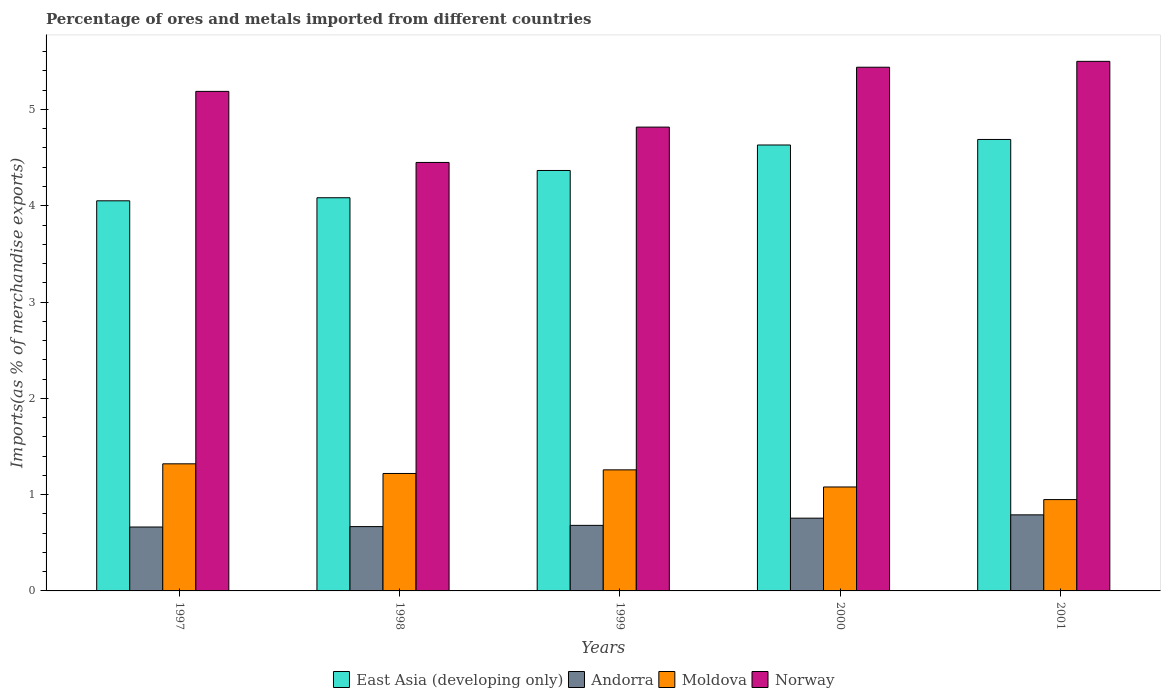How many different coloured bars are there?
Your answer should be very brief. 4. How many groups of bars are there?
Your answer should be very brief. 5. Are the number of bars on each tick of the X-axis equal?
Your answer should be very brief. Yes. In how many cases, is the number of bars for a given year not equal to the number of legend labels?
Make the answer very short. 0. What is the percentage of imports to different countries in Moldova in 2001?
Offer a very short reply. 0.95. Across all years, what is the maximum percentage of imports to different countries in East Asia (developing only)?
Your answer should be very brief. 4.69. Across all years, what is the minimum percentage of imports to different countries in Norway?
Your answer should be very brief. 4.45. In which year was the percentage of imports to different countries in Moldova maximum?
Your answer should be compact. 1997. In which year was the percentage of imports to different countries in Andorra minimum?
Provide a succinct answer. 1997. What is the total percentage of imports to different countries in Andorra in the graph?
Keep it short and to the point. 3.56. What is the difference between the percentage of imports to different countries in East Asia (developing only) in 2000 and that in 2001?
Provide a succinct answer. -0.06. What is the difference between the percentage of imports to different countries in Andorra in 1998 and the percentage of imports to different countries in Norway in 1997?
Give a very brief answer. -4.52. What is the average percentage of imports to different countries in Norway per year?
Your answer should be compact. 5.08. In the year 1999, what is the difference between the percentage of imports to different countries in Moldova and percentage of imports to different countries in Andorra?
Provide a short and direct response. 0.58. In how many years, is the percentage of imports to different countries in Moldova greater than 2.4 %?
Give a very brief answer. 0. What is the ratio of the percentage of imports to different countries in East Asia (developing only) in 1998 to that in 2001?
Provide a succinct answer. 0.87. Is the percentage of imports to different countries in East Asia (developing only) in 1998 less than that in 2001?
Your answer should be compact. Yes. What is the difference between the highest and the second highest percentage of imports to different countries in Norway?
Make the answer very short. 0.06. What is the difference between the highest and the lowest percentage of imports to different countries in East Asia (developing only)?
Keep it short and to the point. 0.64. In how many years, is the percentage of imports to different countries in Norway greater than the average percentage of imports to different countries in Norway taken over all years?
Give a very brief answer. 3. What does the 1st bar from the left in 2000 represents?
Your response must be concise. East Asia (developing only). What does the 2nd bar from the right in 1998 represents?
Ensure brevity in your answer.  Moldova. How many bars are there?
Your response must be concise. 20. Are all the bars in the graph horizontal?
Your answer should be very brief. No. What is the difference between two consecutive major ticks on the Y-axis?
Provide a succinct answer. 1. Are the values on the major ticks of Y-axis written in scientific E-notation?
Your answer should be very brief. No. Does the graph contain grids?
Your answer should be compact. No. Where does the legend appear in the graph?
Give a very brief answer. Bottom center. How are the legend labels stacked?
Offer a very short reply. Horizontal. What is the title of the graph?
Your answer should be very brief. Percentage of ores and metals imported from different countries. Does "El Salvador" appear as one of the legend labels in the graph?
Your answer should be compact. No. What is the label or title of the Y-axis?
Offer a very short reply. Imports(as % of merchandise exports). What is the Imports(as % of merchandise exports) in East Asia (developing only) in 1997?
Provide a short and direct response. 4.05. What is the Imports(as % of merchandise exports) in Andorra in 1997?
Offer a very short reply. 0.66. What is the Imports(as % of merchandise exports) of Moldova in 1997?
Your answer should be compact. 1.32. What is the Imports(as % of merchandise exports) in Norway in 1997?
Your response must be concise. 5.19. What is the Imports(as % of merchandise exports) of East Asia (developing only) in 1998?
Offer a very short reply. 4.08. What is the Imports(as % of merchandise exports) of Andorra in 1998?
Offer a terse response. 0.67. What is the Imports(as % of merchandise exports) in Moldova in 1998?
Keep it short and to the point. 1.22. What is the Imports(as % of merchandise exports) in Norway in 1998?
Provide a succinct answer. 4.45. What is the Imports(as % of merchandise exports) in East Asia (developing only) in 1999?
Your response must be concise. 4.37. What is the Imports(as % of merchandise exports) in Andorra in 1999?
Keep it short and to the point. 0.68. What is the Imports(as % of merchandise exports) in Moldova in 1999?
Provide a short and direct response. 1.26. What is the Imports(as % of merchandise exports) of Norway in 1999?
Provide a succinct answer. 4.82. What is the Imports(as % of merchandise exports) in East Asia (developing only) in 2000?
Your answer should be compact. 4.63. What is the Imports(as % of merchandise exports) in Andorra in 2000?
Give a very brief answer. 0.76. What is the Imports(as % of merchandise exports) of Moldova in 2000?
Offer a very short reply. 1.08. What is the Imports(as % of merchandise exports) of Norway in 2000?
Your answer should be compact. 5.44. What is the Imports(as % of merchandise exports) in East Asia (developing only) in 2001?
Offer a terse response. 4.69. What is the Imports(as % of merchandise exports) of Andorra in 2001?
Provide a short and direct response. 0.79. What is the Imports(as % of merchandise exports) of Moldova in 2001?
Offer a terse response. 0.95. What is the Imports(as % of merchandise exports) of Norway in 2001?
Offer a very short reply. 5.5. Across all years, what is the maximum Imports(as % of merchandise exports) of East Asia (developing only)?
Your response must be concise. 4.69. Across all years, what is the maximum Imports(as % of merchandise exports) in Andorra?
Your response must be concise. 0.79. Across all years, what is the maximum Imports(as % of merchandise exports) of Moldova?
Provide a short and direct response. 1.32. Across all years, what is the maximum Imports(as % of merchandise exports) of Norway?
Offer a very short reply. 5.5. Across all years, what is the minimum Imports(as % of merchandise exports) of East Asia (developing only)?
Give a very brief answer. 4.05. Across all years, what is the minimum Imports(as % of merchandise exports) in Andorra?
Give a very brief answer. 0.66. Across all years, what is the minimum Imports(as % of merchandise exports) of Moldova?
Offer a very short reply. 0.95. Across all years, what is the minimum Imports(as % of merchandise exports) in Norway?
Ensure brevity in your answer.  4.45. What is the total Imports(as % of merchandise exports) of East Asia (developing only) in the graph?
Make the answer very short. 21.82. What is the total Imports(as % of merchandise exports) in Andorra in the graph?
Make the answer very short. 3.56. What is the total Imports(as % of merchandise exports) of Moldova in the graph?
Offer a terse response. 5.83. What is the total Imports(as % of merchandise exports) in Norway in the graph?
Offer a terse response. 25.39. What is the difference between the Imports(as % of merchandise exports) of East Asia (developing only) in 1997 and that in 1998?
Your answer should be very brief. -0.03. What is the difference between the Imports(as % of merchandise exports) in Andorra in 1997 and that in 1998?
Provide a short and direct response. -0. What is the difference between the Imports(as % of merchandise exports) in Moldova in 1997 and that in 1998?
Your answer should be very brief. 0.1. What is the difference between the Imports(as % of merchandise exports) in Norway in 1997 and that in 1998?
Provide a short and direct response. 0.74. What is the difference between the Imports(as % of merchandise exports) in East Asia (developing only) in 1997 and that in 1999?
Offer a terse response. -0.32. What is the difference between the Imports(as % of merchandise exports) of Andorra in 1997 and that in 1999?
Your answer should be compact. -0.02. What is the difference between the Imports(as % of merchandise exports) in Moldova in 1997 and that in 1999?
Offer a very short reply. 0.06. What is the difference between the Imports(as % of merchandise exports) of Norway in 1997 and that in 1999?
Offer a very short reply. 0.37. What is the difference between the Imports(as % of merchandise exports) of East Asia (developing only) in 1997 and that in 2000?
Offer a very short reply. -0.58. What is the difference between the Imports(as % of merchandise exports) in Andorra in 1997 and that in 2000?
Offer a very short reply. -0.09. What is the difference between the Imports(as % of merchandise exports) of Moldova in 1997 and that in 2000?
Make the answer very short. 0.24. What is the difference between the Imports(as % of merchandise exports) in Norway in 1997 and that in 2000?
Offer a terse response. -0.25. What is the difference between the Imports(as % of merchandise exports) of East Asia (developing only) in 1997 and that in 2001?
Your response must be concise. -0.64. What is the difference between the Imports(as % of merchandise exports) of Andorra in 1997 and that in 2001?
Your response must be concise. -0.13. What is the difference between the Imports(as % of merchandise exports) in Moldova in 1997 and that in 2001?
Offer a terse response. 0.37. What is the difference between the Imports(as % of merchandise exports) in Norway in 1997 and that in 2001?
Keep it short and to the point. -0.31. What is the difference between the Imports(as % of merchandise exports) in East Asia (developing only) in 1998 and that in 1999?
Provide a short and direct response. -0.28. What is the difference between the Imports(as % of merchandise exports) in Andorra in 1998 and that in 1999?
Provide a short and direct response. -0.01. What is the difference between the Imports(as % of merchandise exports) in Moldova in 1998 and that in 1999?
Your answer should be compact. -0.04. What is the difference between the Imports(as % of merchandise exports) of Norway in 1998 and that in 1999?
Provide a succinct answer. -0.37. What is the difference between the Imports(as % of merchandise exports) in East Asia (developing only) in 1998 and that in 2000?
Offer a very short reply. -0.55. What is the difference between the Imports(as % of merchandise exports) of Andorra in 1998 and that in 2000?
Ensure brevity in your answer.  -0.09. What is the difference between the Imports(as % of merchandise exports) of Moldova in 1998 and that in 2000?
Give a very brief answer. 0.14. What is the difference between the Imports(as % of merchandise exports) of Norway in 1998 and that in 2000?
Offer a terse response. -0.99. What is the difference between the Imports(as % of merchandise exports) in East Asia (developing only) in 1998 and that in 2001?
Give a very brief answer. -0.61. What is the difference between the Imports(as % of merchandise exports) in Andorra in 1998 and that in 2001?
Ensure brevity in your answer.  -0.12. What is the difference between the Imports(as % of merchandise exports) of Moldova in 1998 and that in 2001?
Your response must be concise. 0.27. What is the difference between the Imports(as % of merchandise exports) of Norway in 1998 and that in 2001?
Ensure brevity in your answer.  -1.05. What is the difference between the Imports(as % of merchandise exports) of East Asia (developing only) in 1999 and that in 2000?
Offer a terse response. -0.26. What is the difference between the Imports(as % of merchandise exports) of Andorra in 1999 and that in 2000?
Keep it short and to the point. -0.07. What is the difference between the Imports(as % of merchandise exports) in Moldova in 1999 and that in 2000?
Offer a terse response. 0.18. What is the difference between the Imports(as % of merchandise exports) of Norway in 1999 and that in 2000?
Your response must be concise. -0.62. What is the difference between the Imports(as % of merchandise exports) in East Asia (developing only) in 1999 and that in 2001?
Make the answer very short. -0.32. What is the difference between the Imports(as % of merchandise exports) of Andorra in 1999 and that in 2001?
Provide a succinct answer. -0.11. What is the difference between the Imports(as % of merchandise exports) of Moldova in 1999 and that in 2001?
Offer a very short reply. 0.31. What is the difference between the Imports(as % of merchandise exports) of Norway in 1999 and that in 2001?
Offer a very short reply. -0.68. What is the difference between the Imports(as % of merchandise exports) in East Asia (developing only) in 2000 and that in 2001?
Offer a terse response. -0.06. What is the difference between the Imports(as % of merchandise exports) of Andorra in 2000 and that in 2001?
Provide a short and direct response. -0.03. What is the difference between the Imports(as % of merchandise exports) of Moldova in 2000 and that in 2001?
Your answer should be compact. 0.13. What is the difference between the Imports(as % of merchandise exports) of Norway in 2000 and that in 2001?
Provide a succinct answer. -0.06. What is the difference between the Imports(as % of merchandise exports) in East Asia (developing only) in 1997 and the Imports(as % of merchandise exports) in Andorra in 1998?
Your response must be concise. 3.38. What is the difference between the Imports(as % of merchandise exports) of East Asia (developing only) in 1997 and the Imports(as % of merchandise exports) of Moldova in 1998?
Make the answer very short. 2.83. What is the difference between the Imports(as % of merchandise exports) in East Asia (developing only) in 1997 and the Imports(as % of merchandise exports) in Norway in 1998?
Ensure brevity in your answer.  -0.4. What is the difference between the Imports(as % of merchandise exports) in Andorra in 1997 and the Imports(as % of merchandise exports) in Moldova in 1998?
Keep it short and to the point. -0.56. What is the difference between the Imports(as % of merchandise exports) in Andorra in 1997 and the Imports(as % of merchandise exports) in Norway in 1998?
Offer a terse response. -3.79. What is the difference between the Imports(as % of merchandise exports) of Moldova in 1997 and the Imports(as % of merchandise exports) of Norway in 1998?
Give a very brief answer. -3.13. What is the difference between the Imports(as % of merchandise exports) in East Asia (developing only) in 1997 and the Imports(as % of merchandise exports) in Andorra in 1999?
Ensure brevity in your answer.  3.37. What is the difference between the Imports(as % of merchandise exports) in East Asia (developing only) in 1997 and the Imports(as % of merchandise exports) in Moldova in 1999?
Ensure brevity in your answer.  2.79. What is the difference between the Imports(as % of merchandise exports) of East Asia (developing only) in 1997 and the Imports(as % of merchandise exports) of Norway in 1999?
Your answer should be very brief. -0.77. What is the difference between the Imports(as % of merchandise exports) in Andorra in 1997 and the Imports(as % of merchandise exports) in Moldova in 1999?
Make the answer very short. -0.59. What is the difference between the Imports(as % of merchandise exports) in Andorra in 1997 and the Imports(as % of merchandise exports) in Norway in 1999?
Ensure brevity in your answer.  -4.15. What is the difference between the Imports(as % of merchandise exports) in Moldova in 1997 and the Imports(as % of merchandise exports) in Norway in 1999?
Provide a short and direct response. -3.5. What is the difference between the Imports(as % of merchandise exports) in East Asia (developing only) in 1997 and the Imports(as % of merchandise exports) in Andorra in 2000?
Offer a terse response. 3.3. What is the difference between the Imports(as % of merchandise exports) of East Asia (developing only) in 1997 and the Imports(as % of merchandise exports) of Moldova in 2000?
Give a very brief answer. 2.97. What is the difference between the Imports(as % of merchandise exports) in East Asia (developing only) in 1997 and the Imports(as % of merchandise exports) in Norway in 2000?
Offer a very short reply. -1.39. What is the difference between the Imports(as % of merchandise exports) of Andorra in 1997 and the Imports(as % of merchandise exports) of Moldova in 2000?
Make the answer very short. -0.42. What is the difference between the Imports(as % of merchandise exports) in Andorra in 1997 and the Imports(as % of merchandise exports) in Norway in 2000?
Your answer should be very brief. -4.78. What is the difference between the Imports(as % of merchandise exports) in Moldova in 1997 and the Imports(as % of merchandise exports) in Norway in 2000?
Make the answer very short. -4.12. What is the difference between the Imports(as % of merchandise exports) of East Asia (developing only) in 1997 and the Imports(as % of merchandise exports) of Andorra in 2001?
Offer a terse response. 3.26. What is the difference between the Imports(as % of merchandise exports) in East Asia (developing only) in 1997 and the Imports(as % of merchandise exports) in Moldova in 2001?
Keep it short and to the point. 3.1. What is the difference between the Imports(as % of merchandise exports) in East Asia (developing only) in 1997 and the Imports(as % of merchandise exports) in Norway in 2001?
Make the answer very short. -1.45. What is the difference between the Imports(as % of merchandise exports) of Andorra in 1997 and the Imports(as % of merchandise exports) of Moldova in 2001?
Give a very brief answer. -0.28. What is the difference between the Imports(as % of merchandise exports) of Andorra in 1997 and the Imports(as % of merchandise exports) of Norway in 2001?
Ensure brevity in your answer.  -4.84. What is the difference between the Imports(as % of merchandise exports) of Moldova in 1997 and the Imports(as % of merchandise exports) of Norway in 2001?
Provide a succinct answer. -4.18. What is the difference between the Imports(as % of merchandise exports) in East Asia (developing only) in 1998 and the Imports(as % of merchandise exports) in Andorra in 1999?
Ensure brevity in your answer.  3.4. What is the difference between the Imports(as % of merchandise exports) in East Asia (developing only) in 1998 and the Imports(as % of merchandise exports) in Moldova in 1999?
Offer a very short reply. 2.83. What is the difference between the Imports(as % of merchandise exports) of East Asia (developing only) in 1998 and the Imports(as % of merchandise exports) of Norway in 1999?
Make the answer very short. -0.73. What is the difference between the Imports(as % of merchandise exports) in Andorra in 1998 and the Imports(as % of merchandise exports) in Moldova in 1999?
Provide a short and direct response. -0.59. What is the difference between the Imports(as % of merchandise exports) in Andorra in 1998 and the Imports(as % of merchandise exports) in Norway in 1999?
Your answer should be very brief. -4.15. What is the difference between the Imports(as % of merchandise exports) of Moldova in 1998 and the Imports(as % of merchandise exports) of Norway in 1999?
Give a very brief answer. -3.6. What is the difference between the Imports(as % of merchandise exports) in East Asia (developing only) in 1998 and the Imports(as % of merchandise exports) in Andorra in 2000?
Ensure brevity in your answer.  3.33. What is the difference between the Imports(as % of merchandise exports) in East Asia (developing only) in 1998 and the Imports(as % of merchandise exports) in Moldova in 2000?
Keep it short and to the point. 3. What is the difference between the Imports(as % of merchandise exports) of East Asia (developing only) in 1998 and the Imports(as % of merchandise exports) of Norway in 2000?
Keep it short and to the point. -1.36. What is the difference between the Imports(as % of merchandise exports) in Andorra in 1998 and the Imports(as % of merchandise exports) in Moldova in 2000?
Your response must be concise. -0.41. What is the difference between the Imports(as % of merchandise exports) of Andorra in 1998 and the Imports(as % of merchandise exports) of Norway in 2000?
Provide a short and direct response. -4.77. What is the difference between the Imports(as % of merchandise exports) in Moldova in 1998 and the Imports(as % of merchandise exports) in Norway in 2000?
Ensure brevity in your answer.  -4.22. What is the difference between the Imports(as % of merchandise exports) in East Asia (developing only) in 1998 and the Imports(as % of merchandise exports) in Andorra in 2001?
Ensure brevity in your answer.  3.29. What is the difference between the Imports(as % of merchandise exports) of East Asia (developing only) in 1998 and the Imports(as % of merchandise exports) of Moldova in 2001?
Offer a very short reply. 3.13. What is the difference between the Imports(as % of merchandise exports) in East Asia (developing only) in 1998 and the Imports(as % of merchandise exports) in Norway in 2001?
Your response must be concise. -1.42. What is the difference between the Imports(as % of merchandise exports) of Andorra in 1998 and the Imports(as % of merchandise exports) of Moldova in 2001?
Ensure brevity in your answer.  -0.28. What is the difference between the Imports(as % of merchandise exports) in Andorra in 1998 and the Imports(as % of merchandise exports) in Norway in 2001?
Provide a succinct answer. -4.83. What is the difference between the Imports(as % of merchandise exports) of Moldova in 1998 and the Imports(as % of merchandise exports) of Norway in 2001?
Your answer should be compact. -4.28. What is the difference between the Imports(as % of merchandise exports) in East Asia (developing only) in 1999 and the Imports(as % of merchandise exports) in Andorra in 2000?
Ensure brevity in your answer.  3.61. What is the difference between the Imports(as % of merchandise exports) of East Asia (developing only) in 1999 and the Imports(as % of merchandise exports) of Moldova in 2000?
Make the answer very short. 3.29. What is the difference between the Imports(as % of merchandise exports) of East Asia (developing only) in 1999 and the Imports(as % of merchandise exports) of Norway in 2000?
Offer a terse response. -1.07. What is the difference between the Imports(as % of merchandise exports) in Andorra in 1999 and the Imports(as % of merchandise exports) in Moldova in 2000?
Your response must be concise. -0.4. What is the difference between the Imports(as % of merchandise exports) of Andorra in 1999 and the Imports(as % of merchandise exports) of Norway in 2000?
Your response must be concise. -4.76. What is the difference between the Imports(as % of merchandise exports) in Moldova in 1999 and the Imports(as % of merchandise exports) in Norway in 2000?
Offer a terse response. -4.18. What is the difference between the Imports(as % of merchandise exports) in East Asia (developing only) in 1999 and the Imports(as % of merchandise exports) in Andorra in 2001?
Your response must be concise. 3.58. What is the difference between the Imports(as % of merchandise exports) of East Asia (developing only) in 1999 and the Imports(as % of merchandise exports) of Moldova in 2001?
Your answer should be compact. 3.42. What is the difference between the Imports(as % of merchandise exports) of East Asia (developing only) in 1999 and the Imports(as % of merchandise exports) of Norway in 2001?
Ensure brevity in your answer.  -1.13. What is the difference between the Imports(as % of merchandise exports) in Andorra in 1999 and the Imports(as % of merchandise exports) in Moldova in 2001?
Your answer should be compact. -0.27. What is the difference between the Imports(as % of merchandise exports) in Andorra in 1999 and the Imports(as % of merchandise exports) in Norway in 2001?
Keep it short and to the point. -4.82. What is the difference between the Imports(as % of merchandise exports) of Moldova in 1999 and the Imports(as % of merchandise exports) of Norway in 2001?
Make the answer very short. -4.24. What is the difference between the Imports(as % of merchandise exports) of East Asia (developing only) in 2000 and the Imports(as % of merchandise exports) of Andorra in 2001?
Provide a short and direct response. 3.84. What is the difference between the Imports(as % of merchandise exports) of East Asia (developing only) in 2000 and the Imports(as % of merchandise exports) of Moldova in 2001?
Offer a very short reply. 3.68. What is the difference between the Imports(as % of merchandise exports) of East Asia (developing only) in 2000 and the Imports(as % of merchandise exports) of Norway in 2001?
Your answer should be very brief. -0.87. What is the difference between the Imports(as % of merchandise exports) in Andorra in 2000 and the Imports(as % of merchandise exports) in Moldova in 2001?
Your answer should be compact. -0.19. What is the difference between the Imports(as % of merchandise exports) of Andorra in 2000 and the Imports(as % of merchandise exports) of Norway in 2001?
Keep it short and to the point. -4.74. What is the difference between the Imports(as % of merchandise exports) in Moldova in 2000 and the Imports(as % of merchandise exports) in Norway in 2001?
Provide a short and direct response. -4.42. What is the average Imports(as % of merchandise exports) in East Asia (developing only) per year?
Provide a short and direct response. 4.36. What is the average Imports(as % of merchandise exports) in Andorra per year?
Keep it short and to the point. 0.71. What is the average Imports(as % of merchandise exports) in Moldova per year?
Offer a very short reply. 1.17. What is the average Imports(as % of merchandise exports) in Norway per year?
Give a very brief answer. 5.08. In the year 1997, what is the difference between the Imports(as % of merchandise exports) in East Asia (developing only) and Imports(as % of merchandise exports) in Andorra?
Your response must be concise. 3.39. In the year 1997, what is the difference between the Imports(as % of merchandise exports) of East Asia (developing only) and Imports(as % of merchandise exports) of Moldova?
Provide a succinct answer. 2.73. In the year 1997, what is the difference between the Imports(as % of merchandise exports) of East Asia (developing only) and Imports(as % of merchandise exports) of Norway?
Provide a succinct answer. -1.14. In the year 1997, what is the difference between the Imports(as % of merchandise exports) in Andorra and Imports(as % of merchandise exports) in Moldova?
Offer a very short reply. -0.66. In the year 1997, what is the difference between the Imports(as % of merchandise exports) of Andorra and Imports(as % of merchandise exports) of Norway?
Provide a short and direct response. -4.52. In the year 1997, what is the difference between the Imports(as % of merchandise exports) of Moldova and Imports(as % of merchandise exports) of Norway?
Offer a terse response. -3.87. In the year 1998, what is the difference between the Imports(as % of merchandise exports) of East Asia (developing only) and Imports(as % of merchandise exports) of Andorra?
Your answer should be very brief. 3.42. In the year 1998, what is the difference between the Imports(as % of merchandise exports) of East Asia (developing only) and Imports(as % of merchandise exports) of Moldova?
Provide a succinct answer. 2.86. In the year 1998, what is the difference between the Imports(as % of merchandise exports) of East Asia (developing only) and Imports(as % of merchandise exports) of Norway?
Give a very brief answer. -0.37. In the year 1998, what is the difference between the Imports(as % of merchandise exports) of Andorra and Imports(as % of merchandise exports) of Moldova?
Offer a terse response. -0.55. In the year 1998, what is the difference between the Imports(as % of merchandise exports) in Andorra and Imports(as % of merchandise exports) in Norway?
Ensure brevity in your answer.  -3.78. In the year 1998, what is the difference between the Imports(as % of merchandise exports) of Moldova and Imports(as % of merchandise exports) of Norway?
Your answer should be compact. -3.23. In the year 1999, what is the difference between the Imports(as % of merchandise exports) of East Asia (developing only) and Imports(as % of merchandise exports) of Andorra?
Offer a very short reply. 3.69. In the year 1999, what is the difference between the Imports(as % of merchandise exports) of East Asia (developing only) and Imports(as % of merchandise exports) of Moldova?
Provide a short and direct response. 3.11. In the year 1999, what is the difference between the Imports(as % of merchandise exports) in East Asia (developing only) and Imports(as % of merchandise exports) in Norway?
Your answer should be compact. -0.45. In the year 1999, what is the difference between the Imports(as % of merchandise exports) of Andorra and Imports(as % of merchandise exports) of Moldova?
Offer a terse response. -0.58. In the year 1999, what is the difference between the Imports(as % of merchandise exports) in Andorra and Imports(as % of merchandise exports) in Norway?
Keep it short and to the point. -4.14. In the year 1999, what is the difference between the Imports(as % of merchandise exports) in Moldova and Imports(as % of merchandise exports) in Norway?
Ensure brevity in your answer.  -3.56. In the year 2000, what is the difference between the Imports(as % of merchandise exports) in East Asia (developing only) and Imports(as % of merchandise exports) in Andorra?
Make the answer very short. 3.88. In the year 2000, what is the difference between the Imports(as % of merchandise exports) of East Asia (developing only) and Imports(as % of merchandise exports) of Moldova?
Provide a succinct answer. 3.55. In the year 2000, what is the difference between the Imports(as % of merchandise exports) in East Asia (developing only) and Imports(as % of merchandise exports) in Norway?
Provide a short and direct response. -0.81. In the year 2000, what is the difference between the Imports(as % of merchandise exports) of Andorra and Imports(as % of merchandise exports) of Moldova?
Give a very brief answer. -0.32. In the year 2000, what is the difference between the Imports(as % of merchandise exports) in Andorra and Imports(as % of merchandise exports) in Norway?
Ensure brevity in your answer.  -4.68. In the year 2000, what is the difference between the Imports(as % of merchandise exports) of Moldova and Imports(as % of merchandise exports) of Norway?
Your response must be concise. -4.36. In the year 2001, what is the difference between the Imports(as % of merchandise exports) of East Asia (developing only) and Imports(as % of merchandise exports) of Andorra?
Make the answer very short. 3.9. In the year 2001, what is the difference between the Imports(as % of merchandise exports) of East Asia (developing only) and Imports(as % of merchandise exports) of Moldova?
Keep it short and to the point. 3.74. In the year 2001, what is the difference between the Imports(as % of merchandise exports) of East Asia (developing only) and Imports(as % of merchandise exports) of Norway?
Ensure brevity in your answer.  -0.81. In the year 2001, what is the difference between the Imports(as % of merchandise exports) in Andorra and Imports(as % of merchandise exports) in Moldova?
Keep it short and to the point. -0.16. In the year 2001, what is the difference between the Imports(as % of merchandise exports) in Andorra and Imports(as % of merchandise exports) in Norway?
Offer a terse response. -4.71. In the year 2001, what is the difference between the Imports(as % of merchandise exports) of Moldova and Imports(as % of merchandise exports) of Norway?
Keep it short and to the point. -4.55. What is the ratio of the Imports(as % of merchandise exports) in Andorra in 1997 to that in 1998?
Your response must be concise. 0.99. What is the ratio of the Imports(as % of merchandise exports) in Moldova in 1997 to that in 1998?
Make the answer very short. 1.08. What is the ratio of the Imports(as % of merchandise exports) in Norway in 1997 to that in 1998?
Offer a terse response. 1.17. What is the ratio of the Imports(as % of merchandise exports) of East Asia (developing only) in 1997 to that in 1999?
Offer a very short reply. 0.93. What is the ratio of the Imports(as % of merchandise exports) of Andorra in 1997 to that in 1999?
Give a very brief answer. 0.98. What is the ratio of the Imports(as % of merchandise exports) in Moldova in 1997 to that in 1999?
Provide a short and direct response. 1.05. What is the ratio of the Imports(as % of merchandise exports) in Norway in 1997 to that in 1999?
Give a very brief answer. 1.08. What is the ratio of the Imports(as % of merchandise exports) of East Asia (developing only) in 1997 to that in 2000?
Provide a short and direct response. 0.87. What is the ratio of the Imports(as % of merchandise exports) in Andorra in 1997 to that in 2000?
Your answer should be very brief. 0.88. What is the ratio of the Imports(as % of merchandise exports) of Moldova in 1997 to that in 2000?
Offer a terse response. 1.22. What is the ratio of the Imports(as % of merchandise exports) in Norway in 1997 to that in 2000?
Offer a terse response. 0.95. What is the ratio of the Imports(as % of merchandise exports) in East Asia (developing only) in 1997 to that in 2001?
Your answer should be very brief. 0.86. What is the ratio of the Imports(as % of merchandise exports) in Andorra in 1997 to that in 2001?
Your answer should be compact. 0.84. What is the ratio of the Imports(as % of merchandise exports) in Moldova in 1997 to that in 2001?
Ensure brevity in your answer.  1.39. What is the ratio of the Imports(as % of merchandise exports) in Norway in 1997 to that in 2001?
Your answer should be very brief. 0.94. What is the ratio of the Imports(as % of merchandise exports) of East Asia (developing only) in 1998 to that in 1999?
Provide a short and direct response. 0.94. What is the ratio of the Imports(as % of merchandise exports) of Andorra in 1998 to that in 1999?
Offer a terse response. 0.98. What is the ratio of the Imports(as % of merchandise exports) in Moldova in 1998 to that in 1999?
Offer a terse response. 0.97. What is the ratio of the Imports(as % of merchandise exports) of Norway in 1998 to that in 1999?
Provide a short and direct response. 0.92. What is the ratio of the Imports(as % of merchandise exports) in East Asia (developing only) in 1998 to that in 2000?
Your answer should be compact. 0.88. What is the ratio of the Imports(as % of merchandise exports) in Andorra in 1998 to that in 2000?
Ensure brevity in your answer.  0.88. What is the ratio of the Imports(as % of merchandise exports) in Moldova in 1998 to that in 2000?
Offer a terse response. 1.13. What is the ratio of the Imports(as % of merchandise exports) in Norway in 1998 to that in 2000?
Ensure brevity in your answer.  0.82. What is the ratio of the Imports(as % of merchandise exports) in East Asia (developing only) in 1998 to that in 2001?
Ensure brevity in your answer.  0.87. What is the ratio of the Imports(as % of merchandise exports) in Andorra in 1998 to that in 2001?
Offer a very short reply. 0.85. What is the ratio of the Imports(as % of merchandise exports) of Moldova in 1998 to that in 2001?
Keep it short and to the point. 1.29. What is the ratio of the Imports(as % of merchandise exports) in Norway in 1998 to that in 2001?
Provide a succinct answer. 0.81. What is the ratio of the Imports(as % of merchandise exports) of East Asia (developing only) in 1999 to that in 2000?
Provide a short and direct response. 0.94. What is the ratio of the Imports(as % of merchandise exports) in Andorra in 1999 to that in 2000?
Your response must be concise. 0.9. What is the ratio of the Imports(as % of merchandise exports) of Moldova in 1999 to that in 2000?
Keep it short and to the point. 1.16. What is the ratio of the Imports(as % of merchandise exports) in Norway in 1999 to that in 2000?
Your response must be concise. 0.89. What is the ratio of the Imports(as % of merchandise exports) of East Asia (developing only) in 1999 to that in 2001?
Keep it short and to the point. 0.93. What is the ratio of the Imports(as % of merchandise exports) in Andorra in 1999 to that in 2001?
Your answer should be very brief. 0.86. What is the ratio of the Imports(as % of merchandise exports) of Moldova in 1999 to that in 2001?
Provide a succinct answer. 1.33. What is the ratio of the Imports(as % of merchandise exports) in Norway in 1999 to that in 2001?
Provide a short and direct response. 0.88. What is the ratio of the Imports(as % of merchandise exports) of East Asia (developing only) in 2000 to that in 2001?
Your answer should be compact. 0.99. What is the ratio of the Imports(as % of merchandise exports) in Andorra in 2000 to that in 2001?
Your answer should be compact. 0.96. What is the ratio of the Imports(as % of merchandise exports) of Moldova in 2000 to that in 2001?
Give a very brief answer. 1.14. What is the ratio of the Imports(as % of merchandise exports) of Norway in 2000 to that in 2001?
Your answer should be compact. 0.99. What is the difference between the highest and the second highest Imports(as % of merchandise exports) of East Asia (developing only)?
Offer a terse response. 0.06. What is the difference between the highest and the second highest Imports(as % of merchandise exports) in Andorra?
Your answer should be very brief. 0.03. What is the difference between the highest and the second highest Imports(as % of merchandise exports) of Moldova?
Your response must be concise. 0.06. What is the difference between the highest and the second highest Imports(as % of merchandise exports) in Norway?
Keep it short and to the point. 0.06. What is the difference between the highest and the lowest Imports(as % of merchandise exports) of East Asia (developing only)?
Your response must be concise. 0.64. What is the difference between the highest and the lowest Imports(as % of merchandise exports) in Andorra?
Offer a very short reply. 0.13. What is the difference between the highest and the lowest Imports(as % of merchandise exports) in Moldova?
Give a very brief answer. 0.37. What is the difference between the highest and the lowest Imports(as % of merchandise exports) in Norway?
Keep it short and to the point. 1.05. 